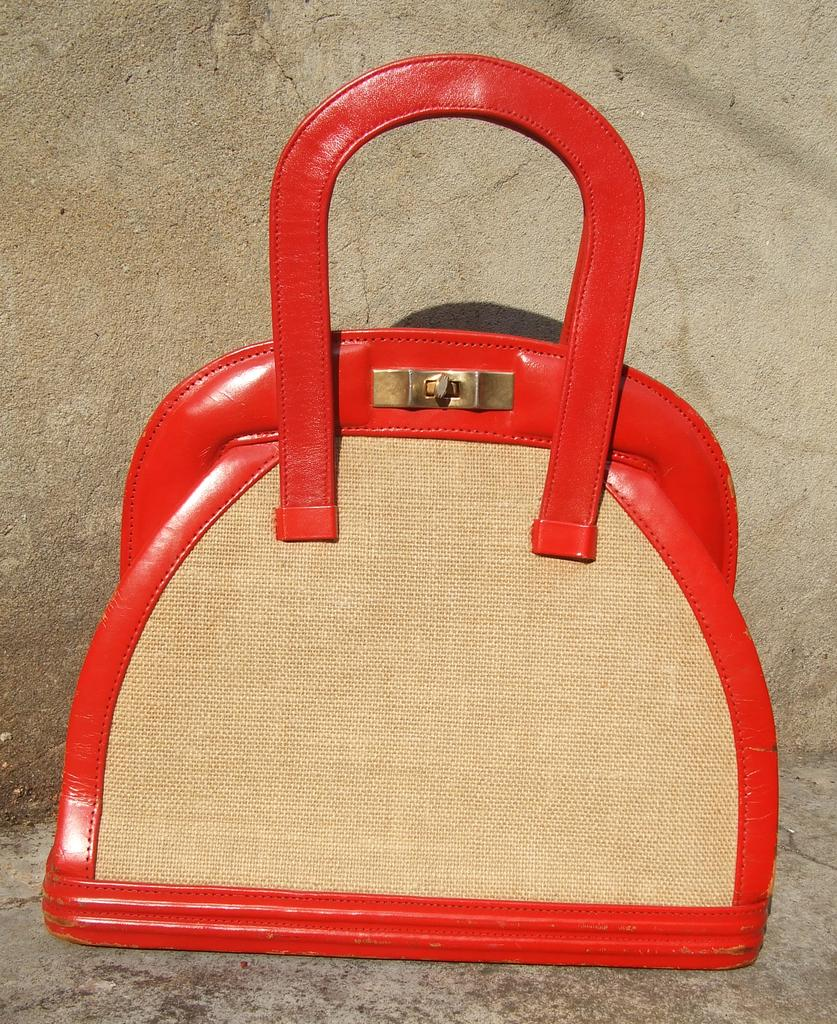What type of accessory is visible in the image? There is a woman's handbag in the image. Can you describe the handbag in more detail? Unfortunately, the image does not provide enough detail to describe the handbag further. What type of fiction book can be seen in the library near the handbag? There is no library or book present in the image; it only features a woman's handbag. How does the sleet affect the appearance of the handbag in the image? There is no sleet present in the image, so its effect on the handbag cannot be determined. 